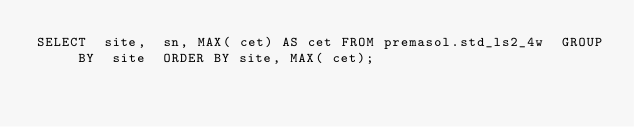Convert code to text. <code><loc_0><loc_0><loc_500><loc_500><_SQL_>SELECT  site,  sn, MAX( cet) AS cet FROM premasol.std_ls2_4w  GROUP BY  site  ORDER BY site, MAX( cet);</code> 